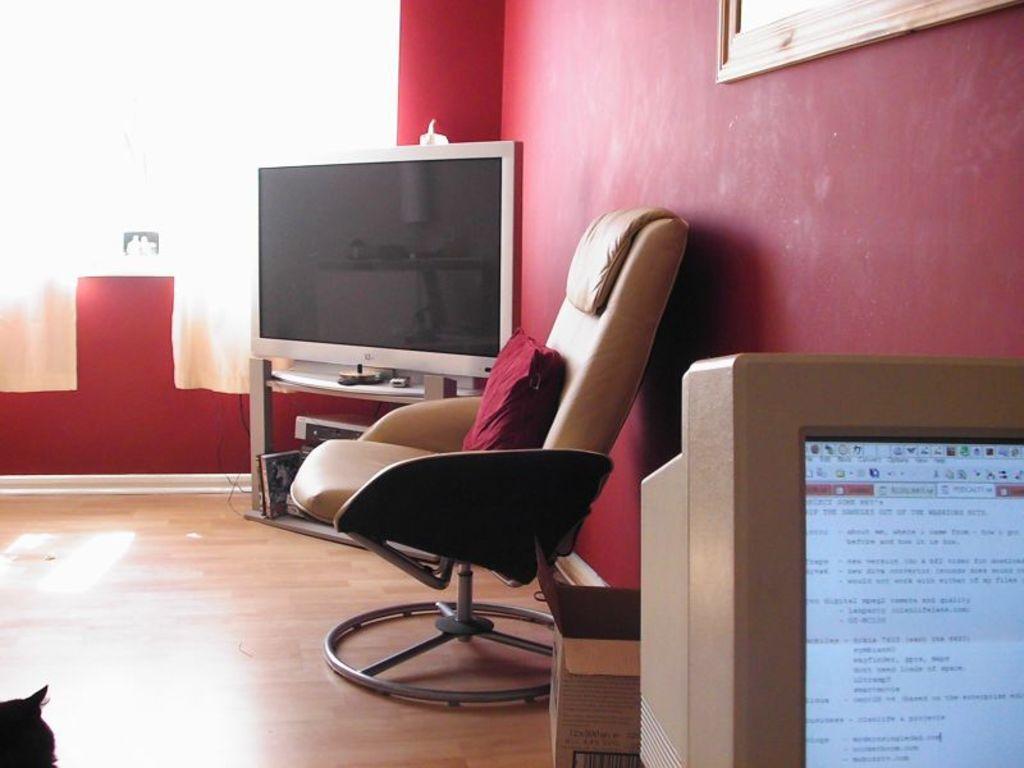Could you give a brief overview of what you see in this image? In a room there is a television, chair, computer monitor, a cat and behind the monitor there is a box kept on the floor, in the background there is a wall and there is a frame kept in front of the wall. 